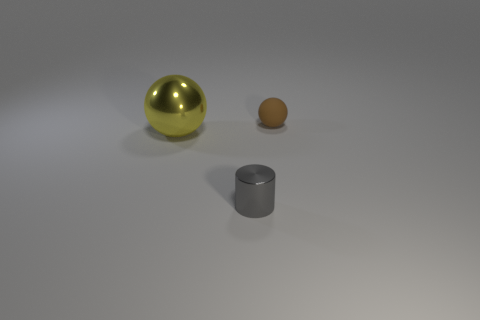Are there any other things that have the same material as the small sphere?
Your response must be concise. No. Is there anything else that has the same shape as the gray object?
Give a very brief answer. No. There is a metallic thing behind the small gray cylinder; what is its color?
Your answer should be compact. Yellow. How many things are either yellow metal objects that are on the left side of the small brown rubber ball or metal objects that are to the left of the cylinder?
Ensure brevity in your answer.  1. Does the matte ball have the same size as the gray shiny object?
Make the answer very short. Yes. What number of cylinders are either large objects or large brown metal things?
Keep it short and to the point. 0. What number of objects are in front of the rubber ball and behind the gray shiny thing?
Give a very brief answer. 1. Is the size of the gray metallic cylinder the same as the ball that is behind the big metallic thing?
Provide a succinct answer. Yes. There is a cylinder that is in front of the sphere that is in front of the tiny brown sphere; are there any balls left of it?
Provide a succinct answer. Yes. What material is the sphere on the right side of the gray shiny cylinder that is in front of the yellow sphere made of?
Offer a terse response. Rubber. 